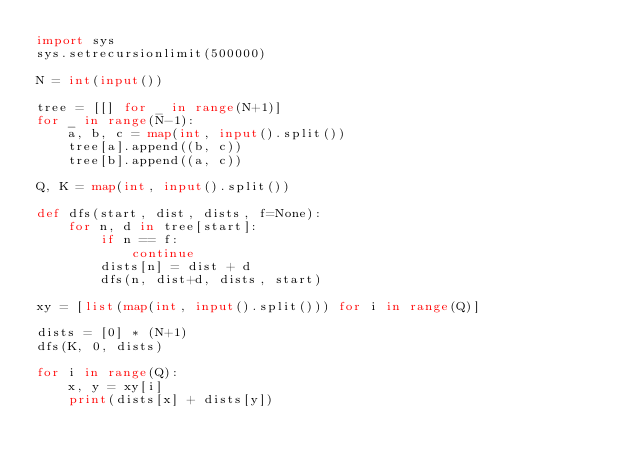<code> <loc_0><loc_0><loc_500><loc_500><_Python_>import sys
sys.setrecursionlimit(500000)

N = int(input())

tree = [[] for _ in range(N+1)]
for _ in range(N-1):
    a, b, c = map(int, input().split())
    tree[a].append((b, c))
    tree[b].append((a, c))

Q, K = map(int, input().split())

def dfs(start, dist, dists, f=None):
    for n, d in tree[start]:
        if n == f:
            continue
        dists[n] = dist + d
        dfs(n, dist+d, dists, start)

xy = [list(map(int, input().split())) for i in range(Q)]

dists = [0] * (N+1)
dfs(K, 0, dists)

for i in range(Q):
    x, y = xy[i]
    print(dists[x] + dists[y])
</code> 